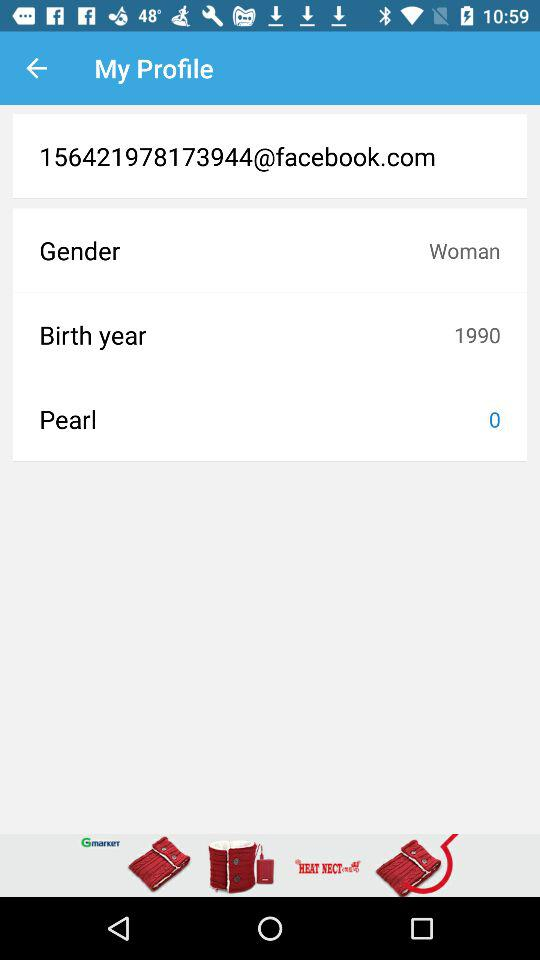What is the birth year of the user? The birth year is 1990. 